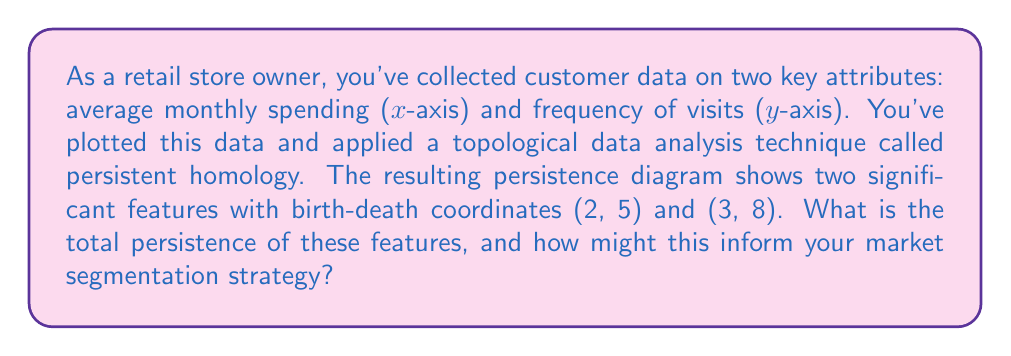Solve this math problem. To solve this problem, we need to understand the concept of persistence in topological data analysis and how it relates to market segmentation:

1. Persistent homology:
   This is a method in topological data analysis that helps identify and measure the significance of features in data. The persistence of a feature is the difference between its death and birth coordinates.

2. Calculating persistence:
   For each feature (b, d), the persistence is calculated as d - b.
   
   Feature 1: (2, 5)
   Persistence = 5 - 2 = 3
   
   Feature 2: (3, 8)
   Persistence = 8 - 3 = 5

3. Total persistence:
   The total persistence is the sum of individual persistences.
   Total persistence = 3 + 5 = 8

4. Interpretation for market segmentation:
   - Higher persistence values indicate more significant or stable features in the data.
   - In this case, the feature with coordinates (3, 8) has a higher persistence (5) than the feature with coordinates (2, 5), which has a persistence of 3.
   - This suggests two distinct customer segments with different characteristics in terms of spending and visit frequency.
   - The segment with higher persistence (5) might represent a more stable or significant customer group, possibly loyal customers with consistent behavior.
   - The segment with lower persistence (3) could represent a secondary customer group with less consistent behavior or a transitional group.

5. Market segmentation strategy:
   - Focus on the two identified segments, particularly the one with higher persistence.
   - Develop targeted marketing strategies and product offerings for each segment.
   - Consider the spending and visit frequency characteristics of each segment when making pricing and inventory decisions.
   - Monitor the less persistent segment for potential growth or transition into the more stable segment.

The total persistence of 8 indicates the overall strength of the segmentation, suggesting that these are meaningful divisions in your customer base that warrant attention in your business strategy.
Answer: The total persistence is 8. This indicates two distinct customer segments with persistences of 3 and 5, suggesting a primary stable segment and a secondary less consistent segment. This information can guide targeted marketing, product selection, and pricing strategies for each segment. 